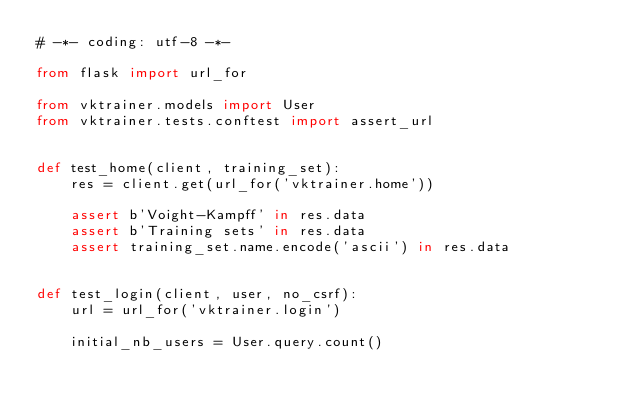Convert code to text. <code><loc_0><loc_0><loc_500><loc_500><_Python_># -*- coding: utf-8 -*-

from flask import url_for

from vktrainer.models import User
from vktrainer.tests.conftest import assert_url


def test_home(client, training_set):
    res = client.get(url_for('vktrainer.home'))

    assert b'Voight-Kampff' in res.data
    assert b'Training sets' in res.data
    assert training_set.name.encode('ascii') in res.data


def test_login(client, user, no_csrf):
    url = url_for('vktrainer.login')

    initial_nb_users = User.query.count()
</code> 